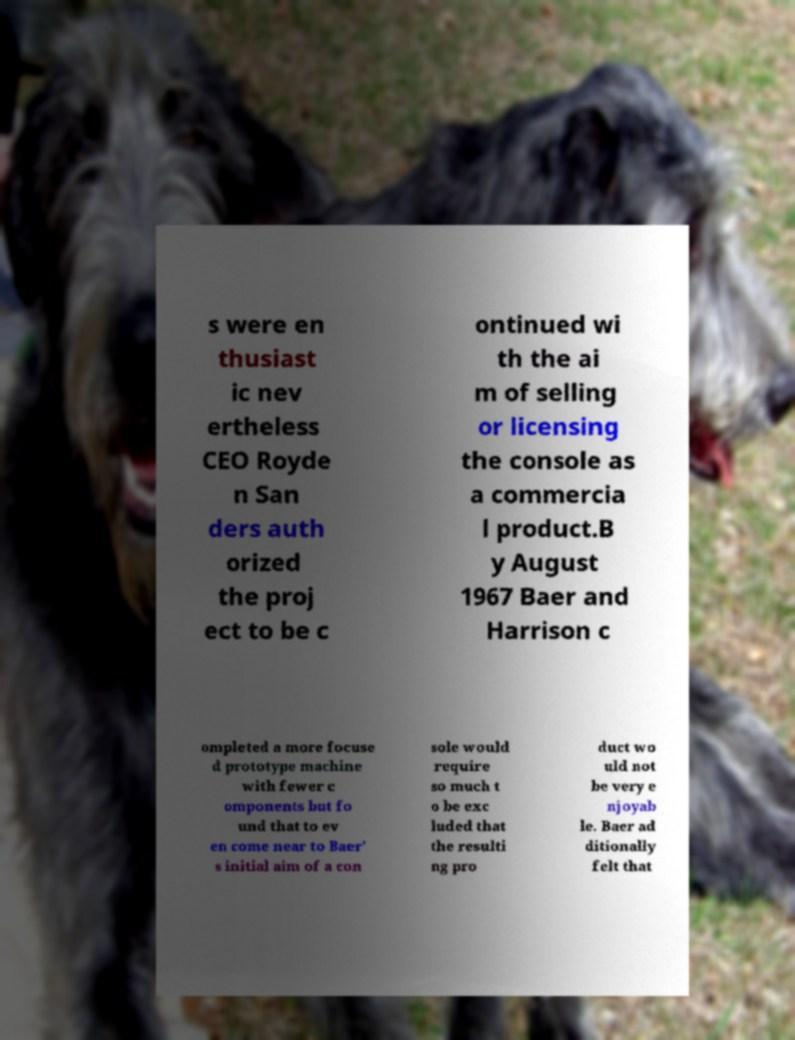Can you read and provide the text displayed in the image?This photo seems to have some interesting text. Can you extract and type it out for me? s were en thusiast ic nev ertheless CEO Royde n San ders auth orized the proj ect to be c ontinued wi th the ai m of selling or licensing the console as a commercia l product.B y August 1967 Baer and Harrison c ompleted a more focuse d prototype machine with fewer c omponents but fo und that to ev en come near to Baer' s initial aim of a con sole would require so much t o be exc luded that the resulti ng pro duct wo uld not be very e njoyab le. Baer ad ditionally felt that 